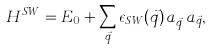Convert formula to latex. <formula><loc_0><loc_0><loc_500><loc_500>H ^ { S W } = E _ { 0 } + \sum _ { \vec { q } } \epsilon _ { S W } ( \vec { q } ) \, a ^ { \dagger } _ { \vec { q } } \, a _ { \vec { q } } ,</formula> 